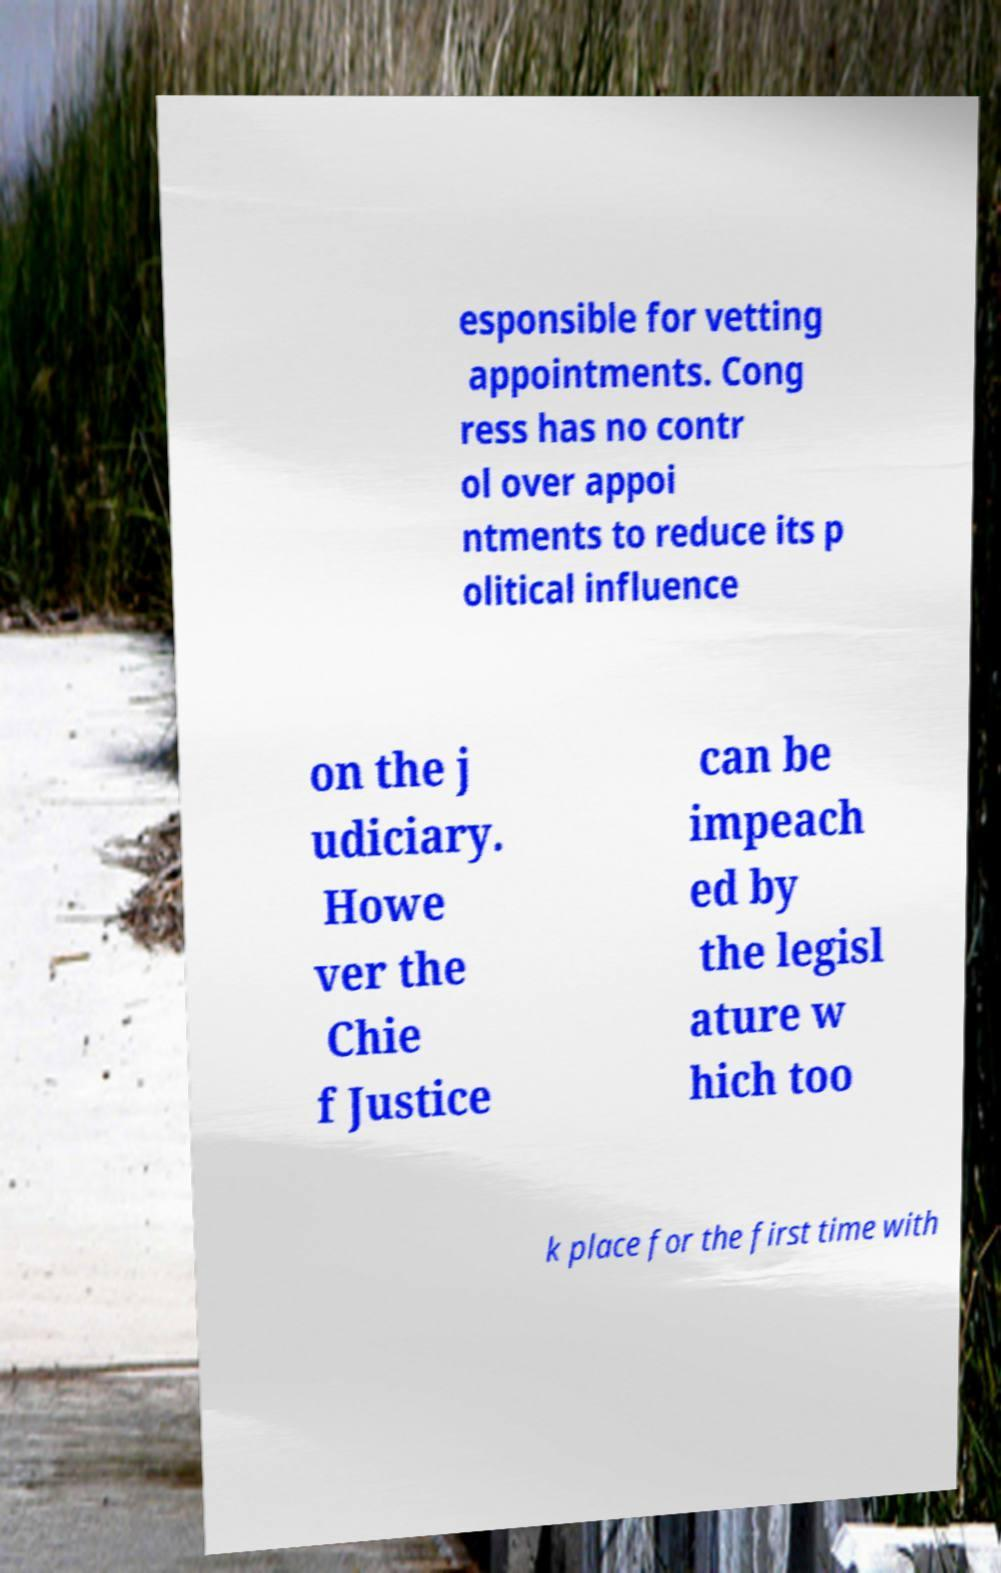Could you assist in decoding the text presented in this image and type it out clearly? esponsible for vetting appointments. Cong ress has no contr ol over appoi ntments to reduce its p olitical influence on the j udiciary. Howe ver the Chie f Justice can be impeach ed by the legisl ature w hich too k place for the first time with 